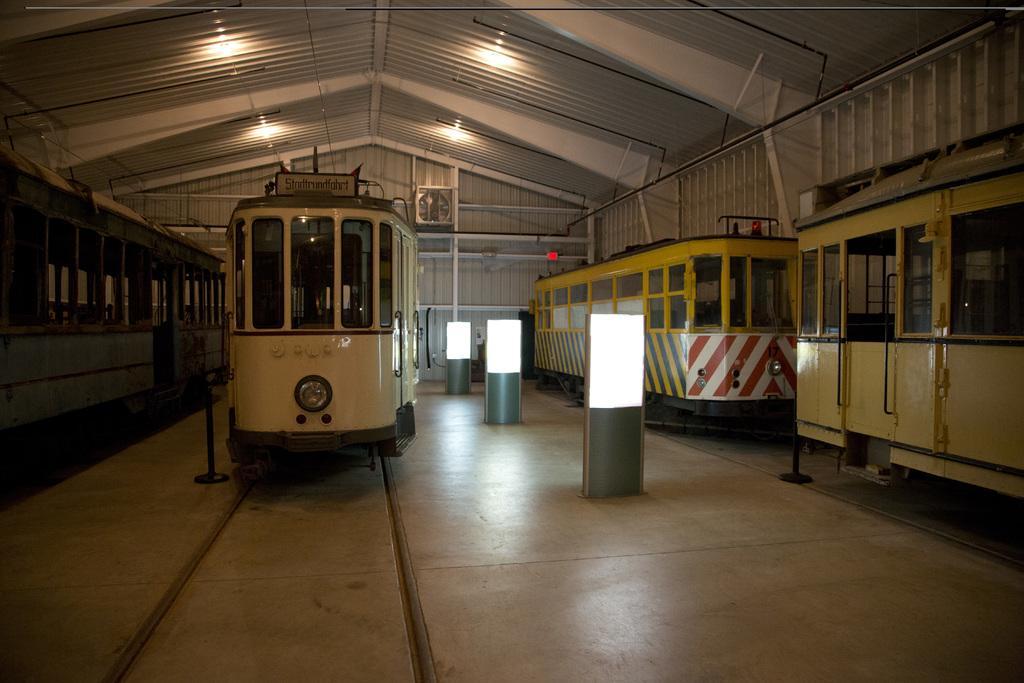How would you summarize this image in a sentence or two? In this image we can see some trains on the track. We can also see some poles with lights on the floor. On the backside we can see a roof with some ceiling lights. 